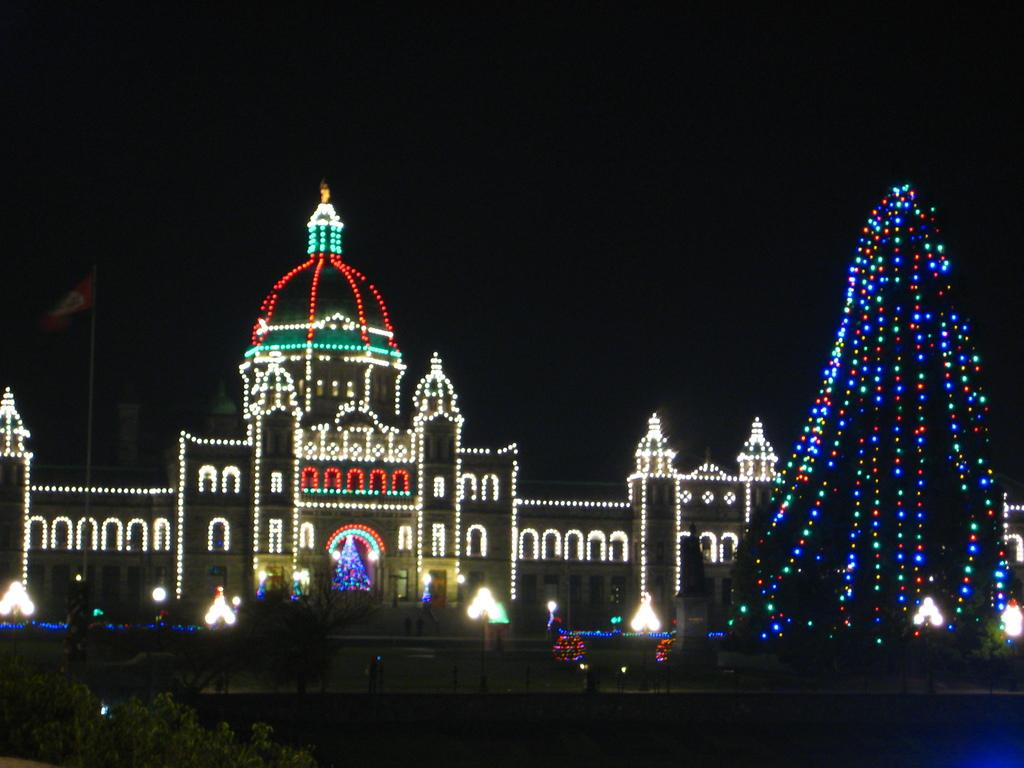What type of vegetation can be seen in the image? There are plants in the image. What is the primary landscape feature in the image? There is a grassland in the image. Are there any structures with decorative elements in the image? Yes, there are decorative lights on a building in the image. What type of veil can be seen covering the plants in the image? There is no veil present in the image; the plants are not covered. What type of expansion is occurring in the image? The image does not depict any expansion; it shows a grassland with plants and a building with decorative lights. 